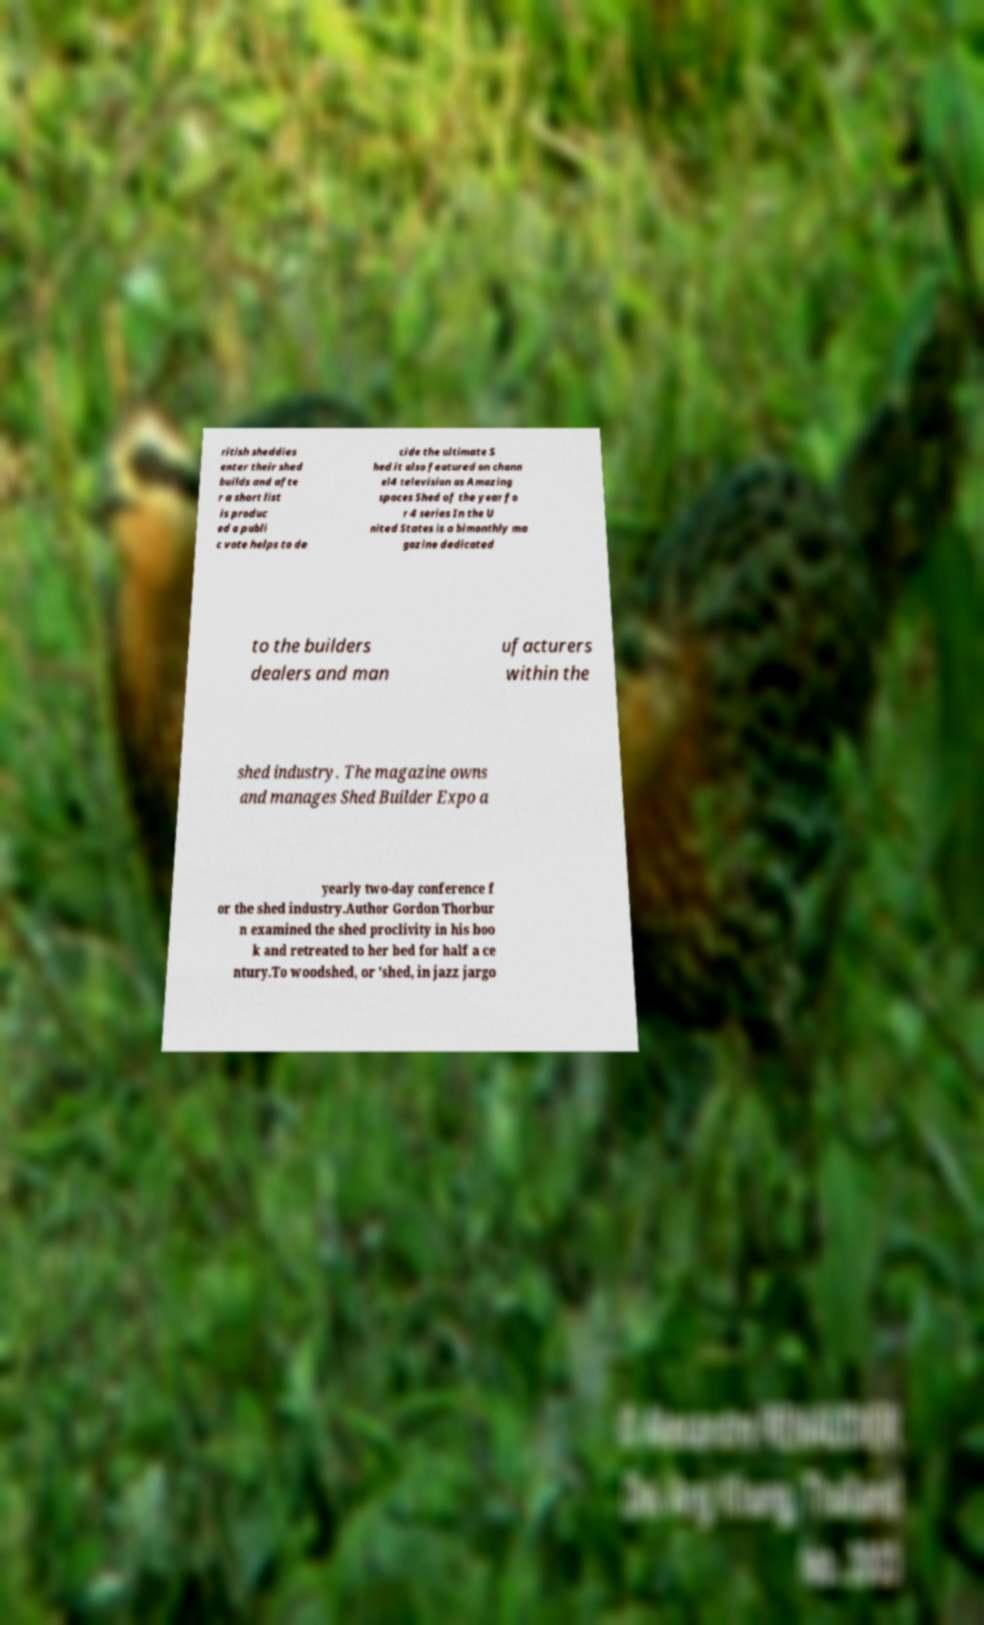Please read and relay the text visible in this image. What does it say? ritish sheddies enter their shed builds and afte r a short list is produc ed a publi c vote helps to de cide the ultimate S hed it also featured on chann el4 television as Amazing spaces Shed of the year fo r 4 series In the U nited States is a bimonthly ma gazine dedicated to the builders dealers and man ufacturers within the shed industry. The magazine owns and manages Shed Builder Expo a yearly two-day conference f or the shed industry.Author Gordon Thorbur n examined the shed proclivity in his boo k and retreated to her bed for half a ce ntury.To woodshed, or 'shed, in jazz jargo 